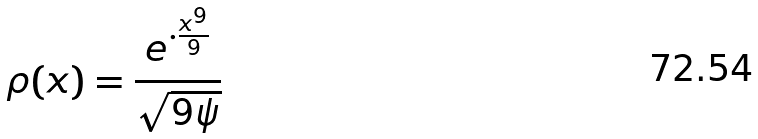Convert formula to latex. <formula><loc_0><loc_0><loc_500><loc_500>\rho ( x ) = \frac { e ^ { \cdot \frac { x ^ { 9 } } { 9 } } } { \sqrt { 9 \psi } }</formula> 